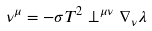<formula> <loc_0><loc_0><loc_500><loc_500>\nu ^ { \mu } = - \sigma T ^ { 2 } \perp ^ { \mu \nu } \nabla _ { \nu } \lambda</formula> 